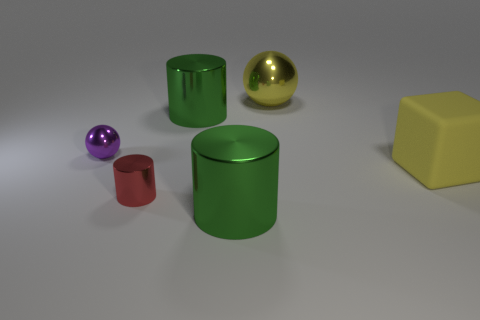Subtract all small red cylinders. How many cylinders are left? 2 Add 4 green objects. How many objects exist? 10 Subtract all yellow spheres. How many spheres are left? 1 Subtract all blocks. How many objects are left? 5 Subtract all red cubes. How many green cylinders are left? 2 Subtract 1 green cylinders. How many objects are left? 5 Subtract 3 cylinders. How many cylinders are left? 0 Subtract all purple blocks. Subtract all green spheres. How many blocks are left? 1 Subtract all purple metallic objects. Subtract all metal things. How many objects are left? 0 Add 2 big things. How many big things are left? 6 